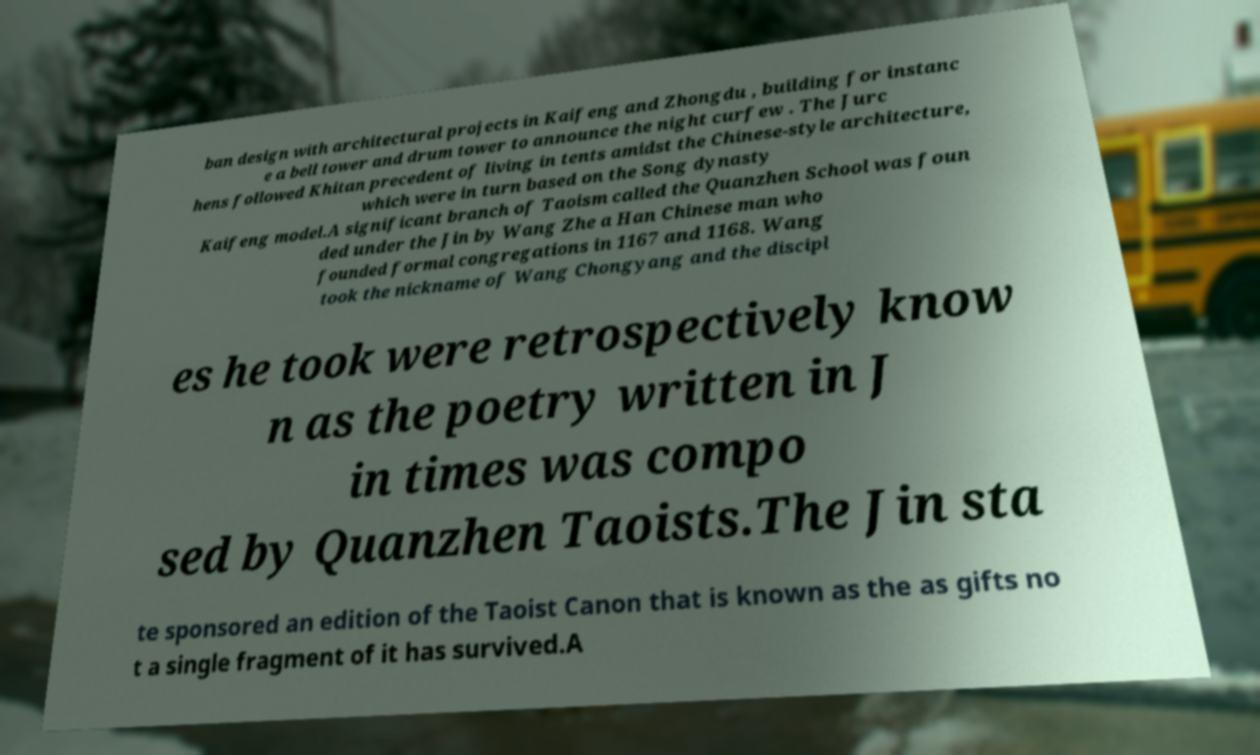Could you assist in decoding the text presented in this image and type it out clearly? ban design with architectural projects in Kaifeng and Zhongdu , building for instanc e a bell tower and drum tower to announce the night curfew . The Jurc hens followed Khitan precedent of living in tents amidst the Chinese-style architecture, which were in turn based on the Song dynasty Kaifeng model.A significant branch of Taoism called the Quanzhen School was foun ded under the Jin by Wang Zhe a Han Chinese man who founded formal congregations in 1167 and 1168. Wang took the nickname of Wang Chongyang and the discipl es he took were retrospectively know n as the poetry written in J in times was compo sed by Quanzhen Taoists.The Jin sta te sponsored an edition of the Taoist Canon that is known as the as gifts no t a single fragment of it has survived.A 